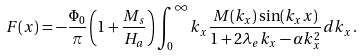Convert formula to latex. <formula><loc_0><loc_0><loc_500><loc_500>F ( x ) = - \frac { \Phi _ { 0 } } { \pi } \left ( 1 + \frac { M _ { s } } { H _ { a } } \right ) \int _ { 0 } ^ { \infty } k _ { x } \frac { M ( k _ { x } ) \sin ( k _ { x } x ) } { 1 + 2 \lambda _ { e } k _ { x } - \alpha k _ { x } ^ { 2 } } d k _ { x } \, .</formula> 